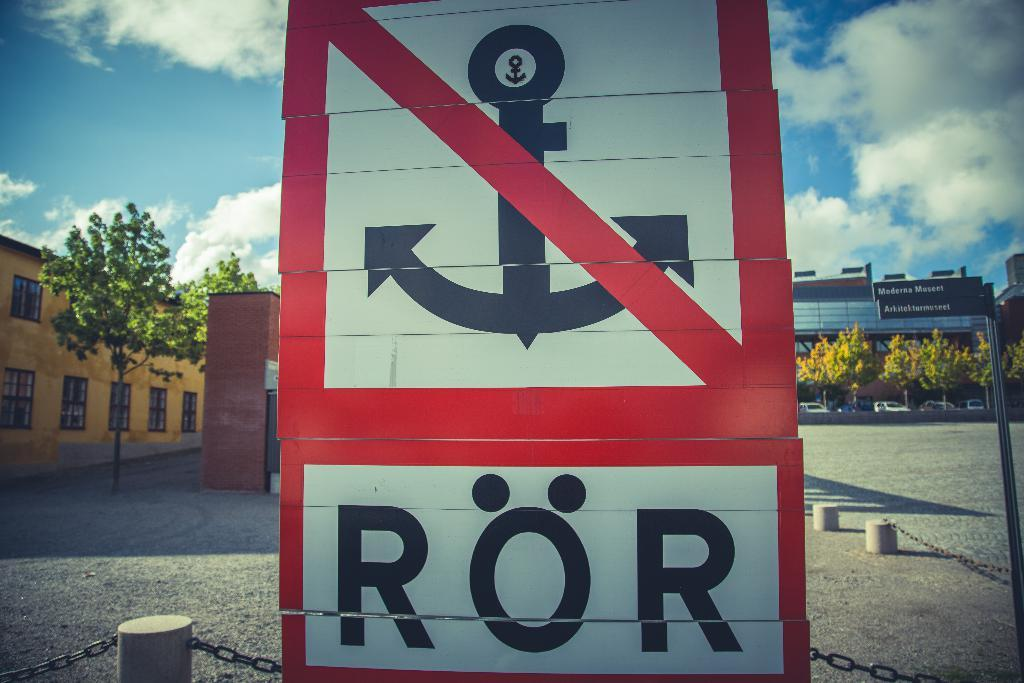<image>
Relay a brief, clear account of the picture shown. A sign with an anchor crossed through with red shows ROR beneath it 